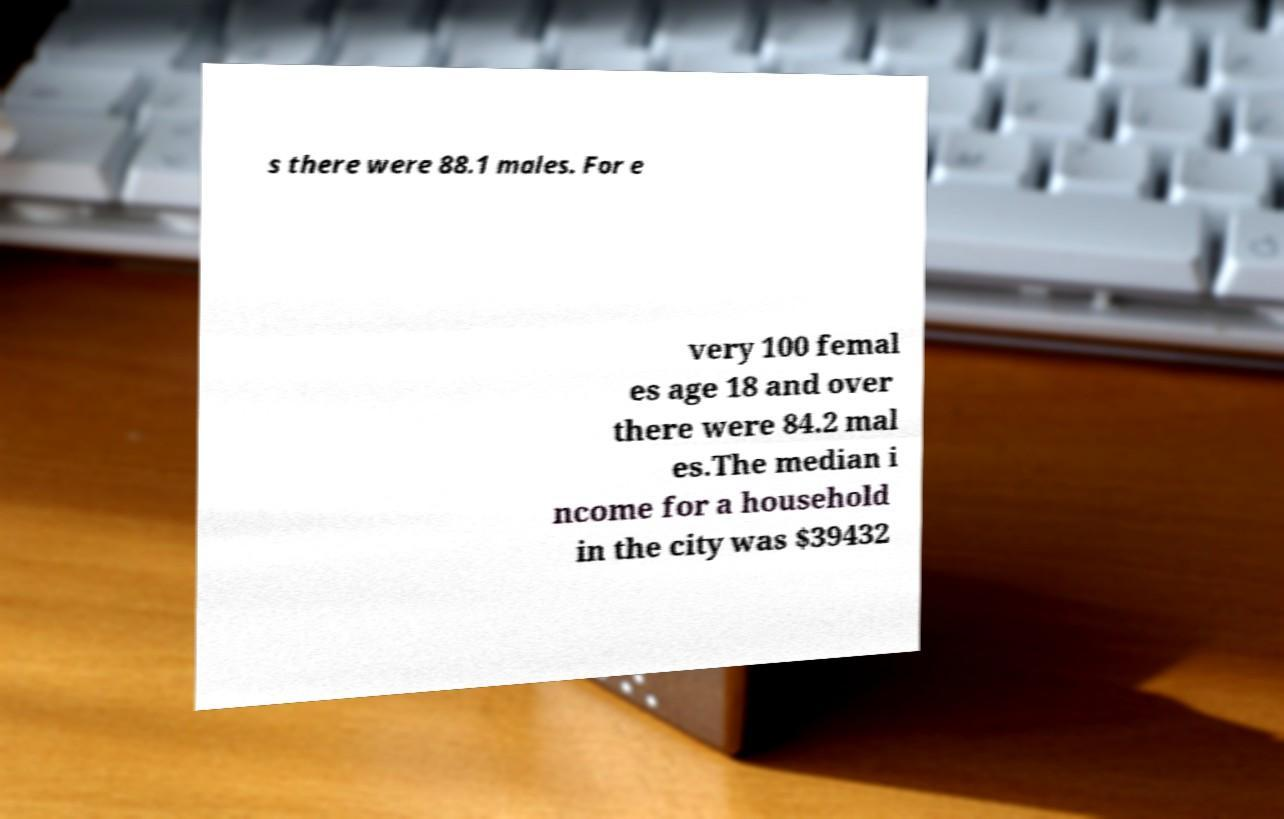Can you read and provide the text displayed in the image?This photo seems to have some interesting text. Can you extract and type it out for me? s there were 88.1 males. For e very 100 femal es age 18 and over there were 84.2 mal es.The median i ncome for a household in the city was $39432 